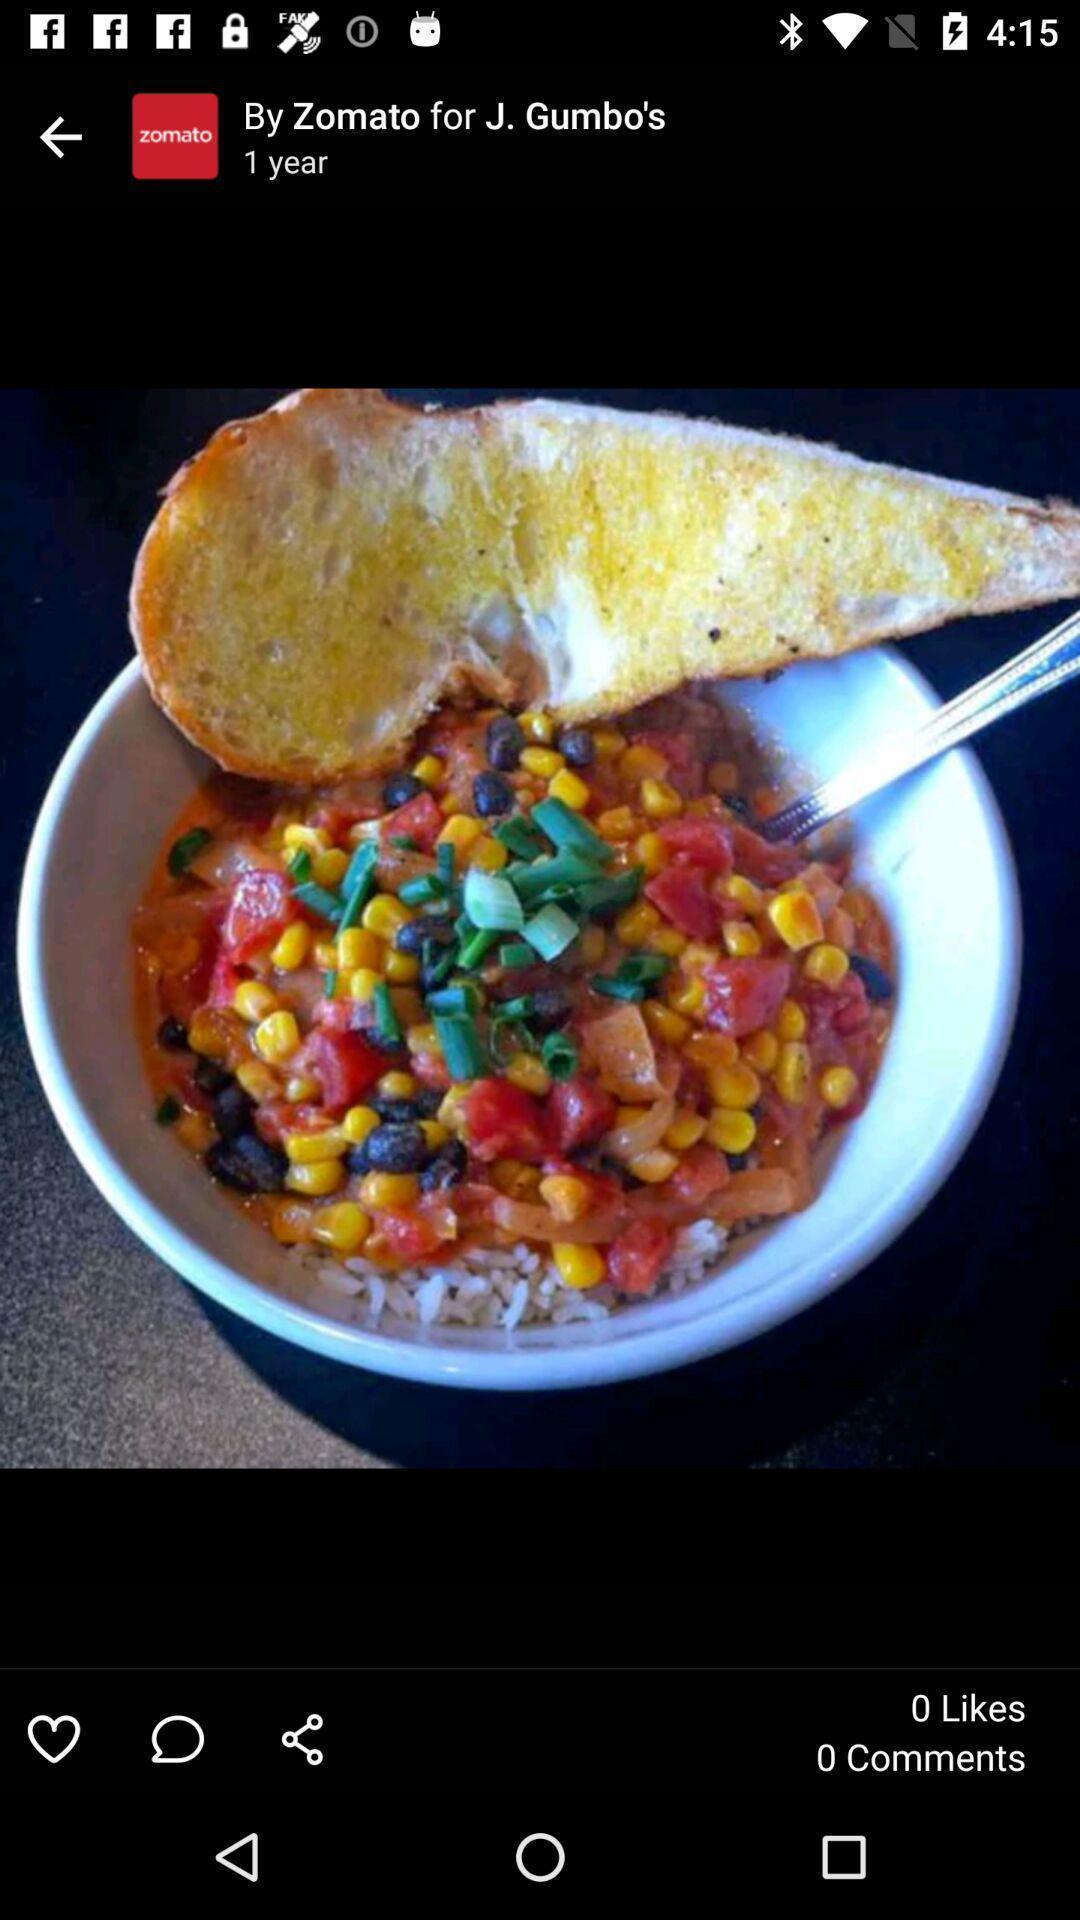Summarize the information in this screenshot. Page shows the a cup of food item on app. 